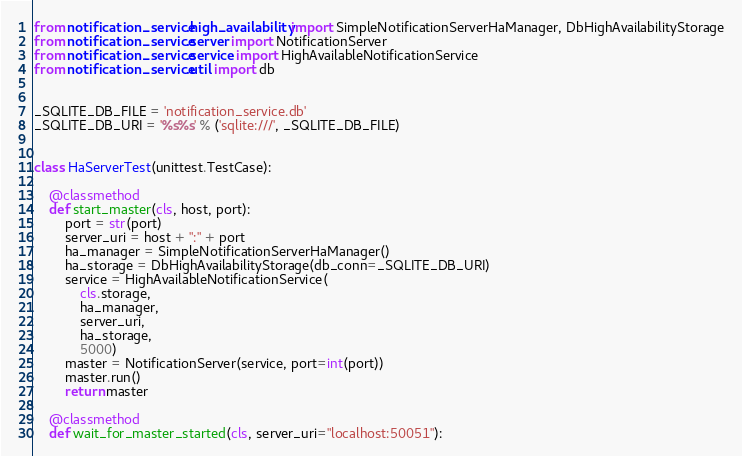Convert code to text. <code><loc_0><loc_0><loc_500><loc_500><_Python_>from notification_service.high_availability import SimpleNotificationServerHaManager, DbHighAvailabilityStorage
from notification_service.server import NotificationServer
from notification_service.service import HighAvailableNotificationService
from notification_service.util import db


_SQLITE_DB_FILE = 'notification_service.db'
_SQLITE_DB_URI = '%s%s' % ('sqlite:///', _SQLITE_DB_FILE)


class HaServerTest(unittest.TestCase):

    @classmethod
    def start_master(cls, host, port):
        port = str(port)
        server_uri = host + ":" + port
        ha_manager = SimpleNotificationServerHaManager()
        ha_storage = DbHighAvailabilityStorage(db_conn=_SQLITE_DB_URI)
        service = HighAvailableNotificationService(
            cls.storage,
            ha_manager,
            server_uri,
            ha_storage,
            5000)
        master = NotificationServer(service, port=int(port))
        master.run()
        return master

    @classmethod
    def wait_for_master_started(cls, server_uri="localhost:50051"):</code> 